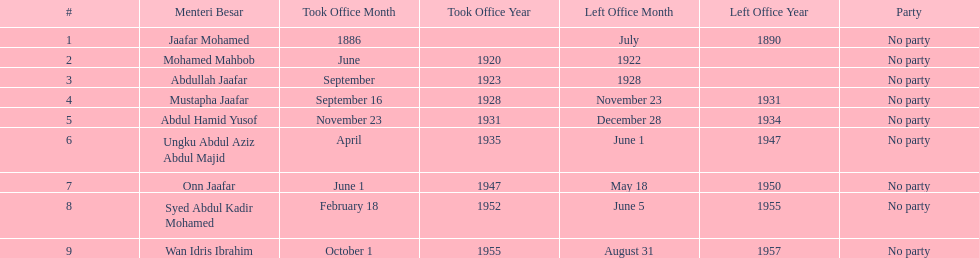Who took office after onn jaafar? Syed Abdul Kadir Mohamed. 